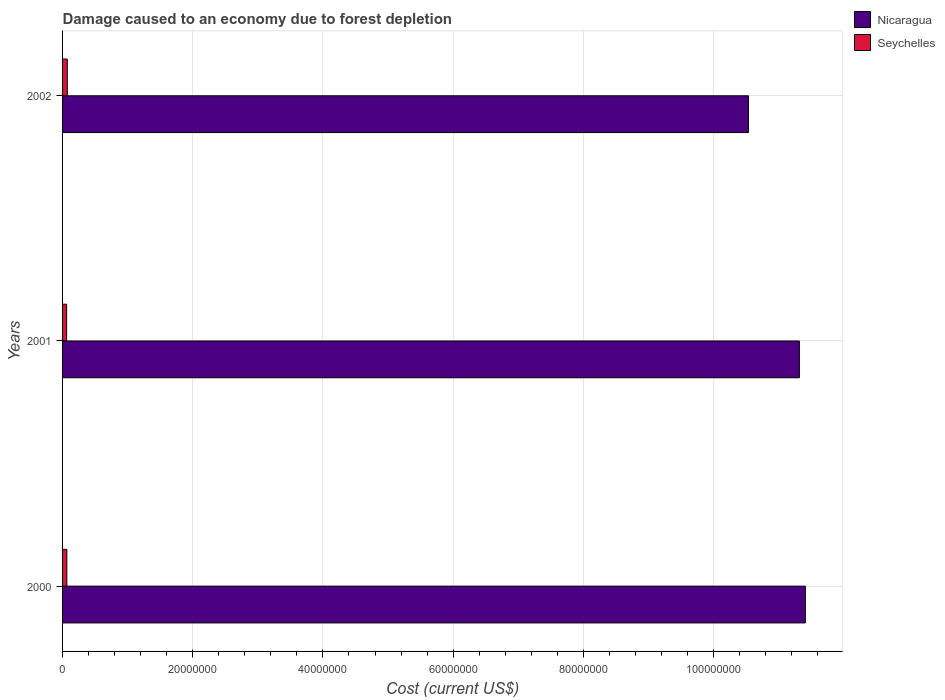Are the number of bars per tick equal to the number of legend labels?
Your answer should be very brief. Yes. Are the number of bars on each tick of the Y-axis equal?
Provide a short and direct response. Yes. What is the cost of damage caused due to forest depletion in Nicaragua in 2000?
Give a very brief answer. 1.14e+08. Across all years, what is the maximum cost of damage caused due to forest depletion in Nicaragua?
Offer a very short reply. 1.14e+08. Across all years, what is the minimum cost of damage caused due to forest depletion in Seychelles?
Your answer should be compact. 6.20e+05. In which year was the cost of damage caused due to forest depletion in Seychelles minimum?
Keep it short and to the point. 2001. What is the total cost of damage caused due to forest depletion in Nicaragua in the graph?
Make the answer very short. 3.33e+08. What is the difference between the cost of damage caused due to forest depletion in Nicaragua in 2000 and that in 2002?
Your response must be concise. 8.74e+06. What is the difference between the cost of damage caused due to forest depletion in Seychelles in 2001 and the cost of damage caused due to forest depletion in Nicaragua in 2002?
Your response must be concise. -1.05e+08. What is the average cost of damage caused due to forest depletion in Nicaragua per year?
Provide a succinct answer. 1.11e+08. In the year 2000, what is the difference between the cost of damage caused due to forest depletion in Seychelles and cost of damage caused due to forest depletion in Nicaragua?
Keep it short and to the point. -1.13e+08. In how many years, is the cost of damage caused due to forest depletion in Nicaragua greater than 52000000 US$?
Provide a succinct answer. 3. What is the ratio of the cost of damage caused due to forest depletion in Nicaragua in 2000 to that in 2001?
Your answer should be very brief. 1.01. Is the difference between the cost of damage caused due to forest depletion in Seychelles in 2000 and 2001 greater than the difference between the cost of damage caused due to forest depletion in Nicaragua in 2000 and 2001?
Offer a very short reply. No. What is the difference between the highest and the second highest cost of damage caused due to forest depletion in Seychelles?
Your answer should be very brief. 6.89e+04. What is the difference between the highest and the lowest cost of damage caused due to forest depletion in Seychelles?
Provide a succinct answer. 1.06e+05. In how many years, is the cost of damage caused due to forest depletion in Nicaragua greater than the average cost of damage caused due to forest depletion in Nicaragua taken over all years?
Give a very brief answer. 2. Is the sum of the cost of damage caused due to forest depletion in Nicaragua in 2001 and 2002 greater than the maximum cost of damage caused due to forest depletion in Seychelles across all years?
Give a very brief answer. Yes. What does the 1st bar from the top in 2000 represents?
Offer a very short reply. Seychelles. What does the 2nd bar from the bottom in 2002 represents?
Provide a short and direct response. Seychelles. How many bars are there?
Your answer should be compact. 6. Are all the bars in the graph horizontal?
Keep it short and to the point. Yes. How many years are there in the graph?
Provide a short and direct response. 3. What is the difference between two consecutive major ticks on the X-axis?
Provide a succinct answer. 2.00e+07. Are the values on the major ticks of X-axis written in scientific E-notation?
Your answer should be compact. No. Does the graph contain any zero values?
Provide a short and direct response. No. How many legend labels are there?
Your answer should be very brief. 2. How are the legend labels stacked?
Offer a very short reply. Vertical. What is the title of the graph?
Provide a short and direct response. Damage caused to an economy due to forest depletion. Does "Fragile and conflict affected situations" appear as one of the legend labels in the graph?
Your response must be concise. No. What is the label or title of the X-axis?
Provide a succinct answer. Cost (current US$). What is the Cost (current US$) in Nicaragua in 2000?
Your answer should be very brief. 1.14e+08. What is the Cost (current US$) in Seychelles in 2000?
Provide a succinct answer. 6.57e+05. What is the Cost (current US$) of Nicaragua in 2001?
Offer a terse response. 1.13e+08. What is the Cost (current US$) of Seychelles in 2001?
Your answer should be compact. 6.20e+05. What is the Cost (current US$) in Nicaragua in 2002?
Provide a succinct answer. 1.05e+08. What is the Cost (current US$) of Seychelles in 2002?
Ensure brevity in your answer.  7.26e+05. Across all years, what is the maximum Cost (current US$) in Nicaragua?
Your answer should be very brief. 1.14e+08. Across all years, what is the maximum Cost (current US$) of Seychelles?
Make the answer very short. 7.26e+05. Across all years, what is the minimum Cost (current US$) of Nicaragua?
Provide a succinct answer. 1.05e+08. Across all years, what is the minimum Cost (current US$) in Seychelles?
Your response must be concise. 6.20e+05. What is the total Cost (current US$) in Nicaragua in the graph?
Provide a short and direct response. 3.33e+08. What is the total Cost (current US$) in Seychelles in the graph?
Your response must be concise. 2.00e+06. What is the difference between the Cost (current US$) in Nicaragua in 2000 and that in 2001?
Give a very brief answer. 9.15e+05. What is the difference between the Cost (current US$) of Seychelles in 2000 and that in 2001?
Your answer should be very brief. 3.70e+04. What is the difference between the Cost (current US$) in Nicaragua in 2000 and that in 2002?
Your answer should be compact. 8.74e+06. What is the difference between the Cost (current US$) of Seychelles in 2000 and that in 2002?
Your answer should be very brief. -6.89e+04. What is the difference between the Cost (current US$) in Nicaragua in 2001 and that in 2002?
Make the answer very short. 7.82e+06. What is the difference between the Cost (current US$) in Seychelles in 2001 and that in 2002?
Your response must be concise. -1.06e+05. What is the difference between the Cost (current US$) of Nicaragua in 2000 and the Cost (current US$) of Seychelles in 2001?
Offer a terse response. 1.13e+08. What is the difference between the Cost (current US$) in Nicaragua in 2000 and the Cost (current US$) in Seychelles in 2002?
Your answer should be compact. 1.13e+08. What is the difference between the Cost (current US$) of Nicaragua in 2001 and the Cost (current US$) of Seychelles in 2002?
Provide a succinct answer. 1.12e+08. What is the average Cost (current US$) in Nicaragua per year?
Your answer should be very brief. 1.11e+08. What is the average Cost (current US$) of Seychelles per year?
Ensure brevity in your answer.  6.68e+05. In the year 2000, what is the difference between the Cost (current US$) in Nicaragua and Cost (current US$) in Seychelles?
Your response must be concise. 1.13e+08. In the year 2001, what is the difference between the Cost (current US$) of Nicaragua and Cost (current US$) of Seychelles?
Offer a terse response. 1.13e+08. In the year 2002, what is the difference between the Cost (current US$) in Nicaragua and Cost (current US$) in Seychelles?
Offer a terse response. 1.05e+08. What is the ratio of the Cost (current US$) in Seychelles in 2000 to that in 2001?
Make the answer very short. 1.06. What is the ratio of the Cost (current US$) of Nicaragua in 2000 to that in 2002?
Your response must be concise. 1.08. What is the ratio of the Cost (current US$) of Seychelles in 2000 to that in 2002?
Your response must be concise. 0.91. What is the ratio of the Cost (current US$) in Nicaragua in 2001 to that in 2002?
Provide a short and direct response. 1.07. What is the ratio of the Cost (current US$) of Seychelles in 2001 to that in 2002?
Provide a succinct answer. 0.85. What is the difference between the highest and the second highest Cost (current US$) of Nicaragua?
Offer a very short reply. 9.15e+05. What is the difference between the highest and the second highest Cost (current US$) in Seychelles?
Offer a terse response. 6.89e+04. What is the difference between the highest and the lowest Cost (current US$) of Nicaragua?
Offer a terse response. 8.74e+06. What is the difference between the highest and the lowest Cost (current US$) of Seychelles?
Your response must be concise. 1.06e+05. 